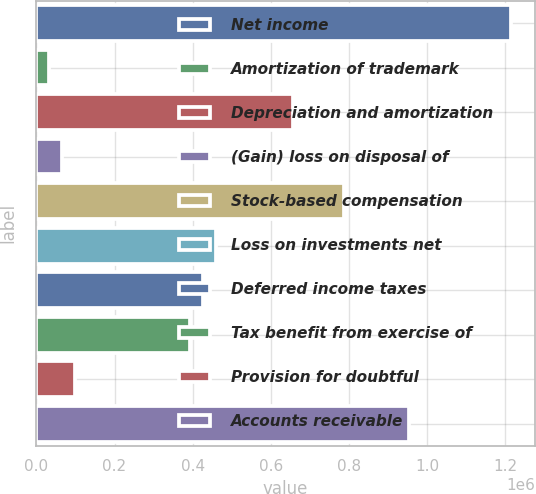Convert chart. <chart><loc_0><loc_0><loc_500><loc_500><bar_chart><fcel>Net income<fcel>Amortization of trademark<fcel>Depreciation and amortization<fcel>(Gain) loss on disposal of<fcel>Stock-based compensation<fcel>Loss on investments net<fcel>Deferred income taxes<fcel>Tax benefit from exercise of<fcel>Provision for doubtful<fcel>Accounts receivable<nl><fcel>1.21476e+06<fcel>32879.9<fcel>656648<fcel>65709.8<fcel>787968<fcel>459669<fcel>426839<fcel>394009<fcel>98539.7<fcel>952117<nl></chart> 